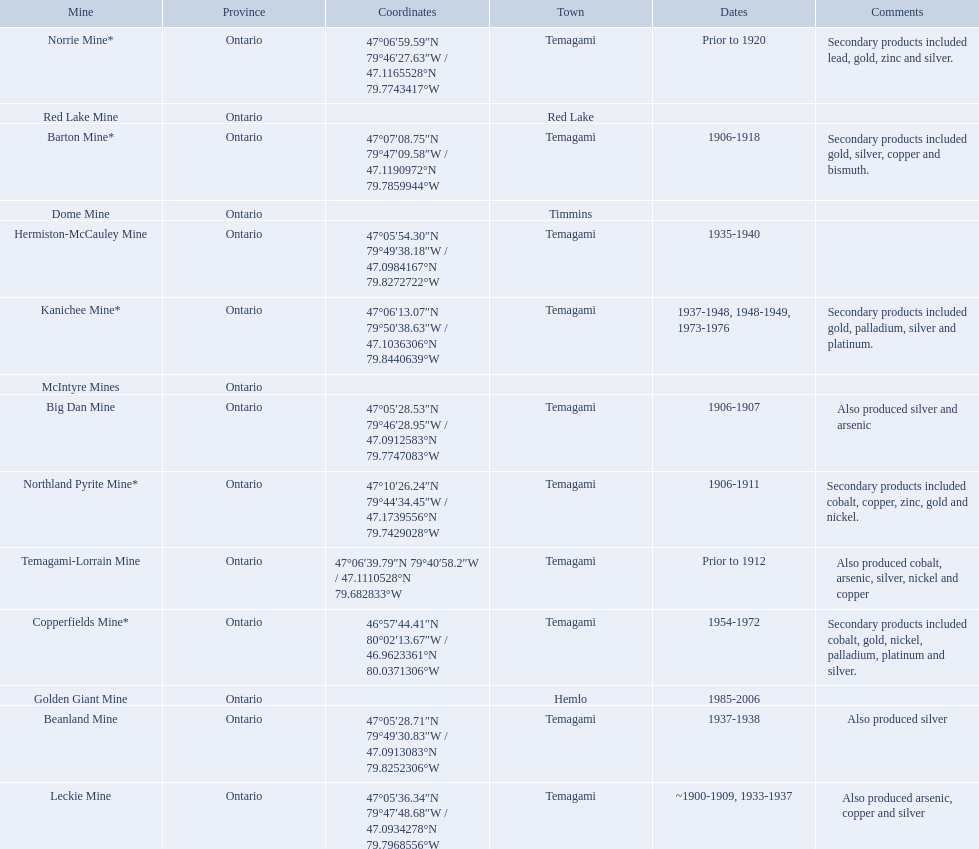What are all the mines with dates listed? Barton Mine*, Beanland Mine, Big Dan Mine, Copperfields Mine*, Golden Giant Mine, Hermiston-McCauley Mine, Kanichee Mine*, Leckie Mine, Norrie Mine*, Northland Pyrite Mine*, Temagami-Lorrain Mine. Which of those dates include the year that the mine was closed? 1906-1918, 1937-1938, 1906-1907, 1954-1972, 1985-2006, 1935-1940, 1937-1948, 1948-1949, 1973-1976, ~1900-1909, 1933-1937, 1906-1911. Which of those mines were opened the longest? Golden Giant Mine. 